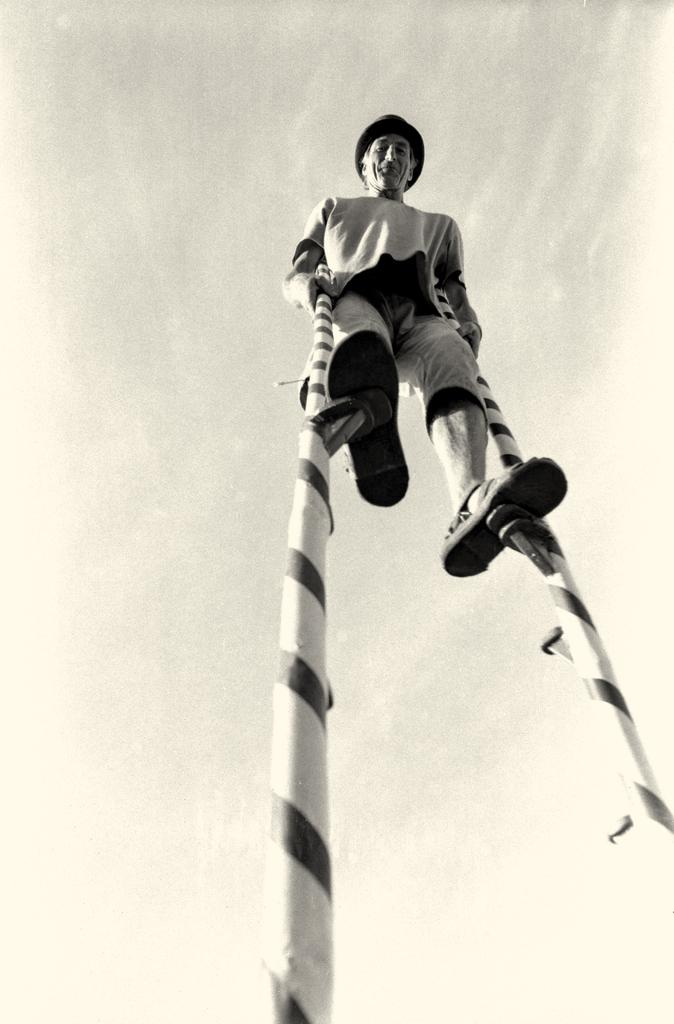What is the color scheme of the image? The image is black and white. Can you describe the main subject in the image? There is a person in the image. What is the person doing in the image? The person is standing on poles. What type of egg is being used in the argument in the image? There is no egg or argument present in the image; it features a person standing on poles in a black and white setting. 